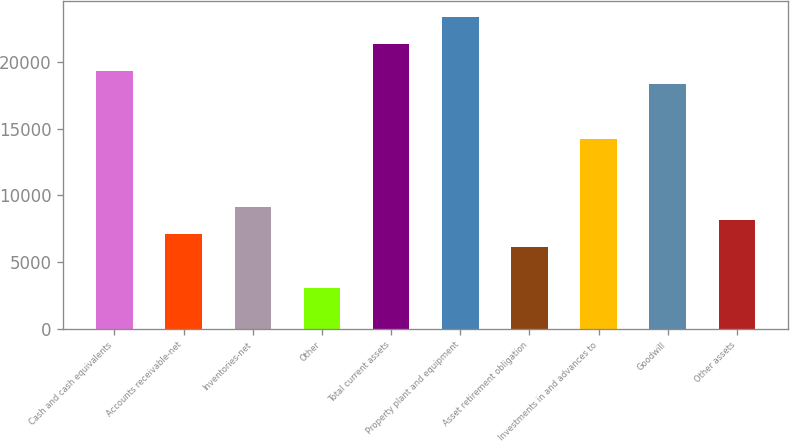<chart> <loc_0><loc_0><loc_500><loc_500><bar_chart><fcel>Cash and cash equivalents<fcel>Accounts receivable-net<fcel>Inventories-net<fcel>Other<fcel>Total current assets<fcel>Property plant and equipment<fcel>Asset retirement obligation<fcel>Investments in and advances to<fcel>Goodwill<fcel>Other assets<nl><fcel>19316.6<fcel>7117.01<fcel>9150.27<fcel>3050.49<fcel>21349.8<fcel>23383.1<fcel>6100.38<fcel>14233.4<fcel>18299.9<fcel>8133.64<nl></chart> 